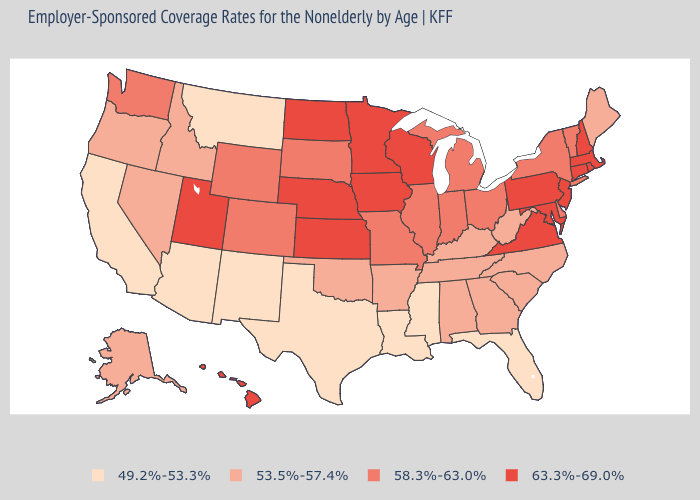Does Louisiana have the highest value in the USA?
Short answer required. No. Which states have the highest value in the USA?
Answer briefly. Connecticut, Hawaii, Iowa, Kansas, Maryland, Massachusetts, Minnesota, Nebraska, New Hampshire, New Jersey, North Dakota, Pennsylvania, Rhode Island, Utah, Virginia, Wisconsin. Is the legend a continuous bar?
Write a very short answer. No. Among the states that border Arkansas , which have the highest value?
Short answer required. Missouri. What is the highest value in the West ?
Keep it brief. 63.3%-69.0%. Does Minnesota have the highest value in the USA?
Short answer required. Yes. Name the states that have a value in the range 63.3%-69.0%?
Short answer required. Connecticut, Hawaii, Iowa, Kansas, Maryland, Massachusetts, Minnesota, Nebraska, New Hampshire, New Jersey, North Dakota, Pennsylvania, Rhode Island, Utah, Virginia, Wisconsin. What is the highest value in states that border Massachusetts?
Answer briefly. 63.3%-69.0%. Among the states that border Delaware , which have the lowest value?
Answer briefly. Maryland, New Jersey, Pennsylvania. Does New Hampshire have the same value as Connecticut?
Keep it brief. Yes. What is the lowest value in the USA?
Concise answer only. 49.2%-53.3%. Among the states that border Louisiana , does Mississippi have the lowest value?
Keep it brief. Yes. Does Idaho have the lowest value in the USA?
Give a very brief answer. No. Does the first symbol in the legend represent the smallest category?
Concise answer only. Yes. 